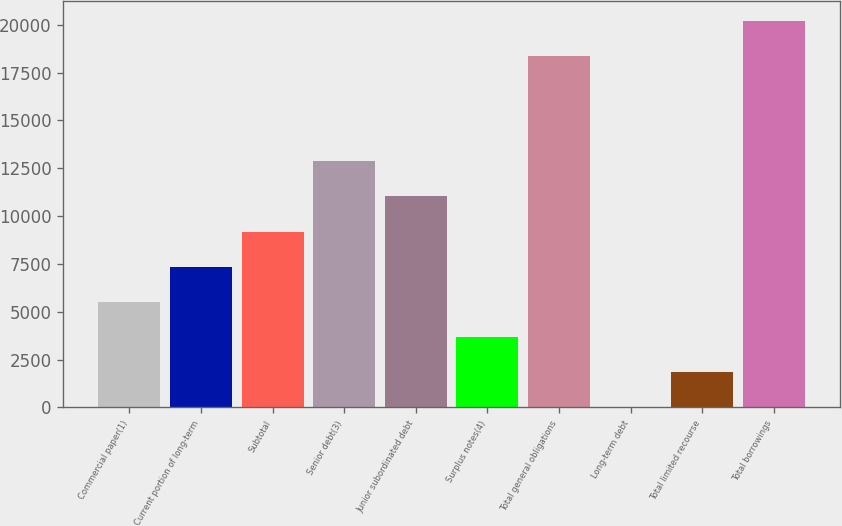Convert chart. <chart><loc_0><loc_0><loc_500><loc_500><bar_chart><fcel>Commercial paper(1)<fcel>Current portion of long-term<fcel>Subtotal<fcel>Senior debt(3)<fcel>Junior subordinated debt<fcel>Surplus notes(4)<fcel>Total general obligations<fcel>Long-term debt<fcel>Total limited recourse<fcel>Total borrowings<nl><fcel>5515.99<fcel>7353.7<fcel>9191.41<fcel>12866.8<fcel>11029.1<fcel>3678.28<fcel>18380<fcel>2.86<fcel>1840.57<fcel>20217.7<nl></chart> 